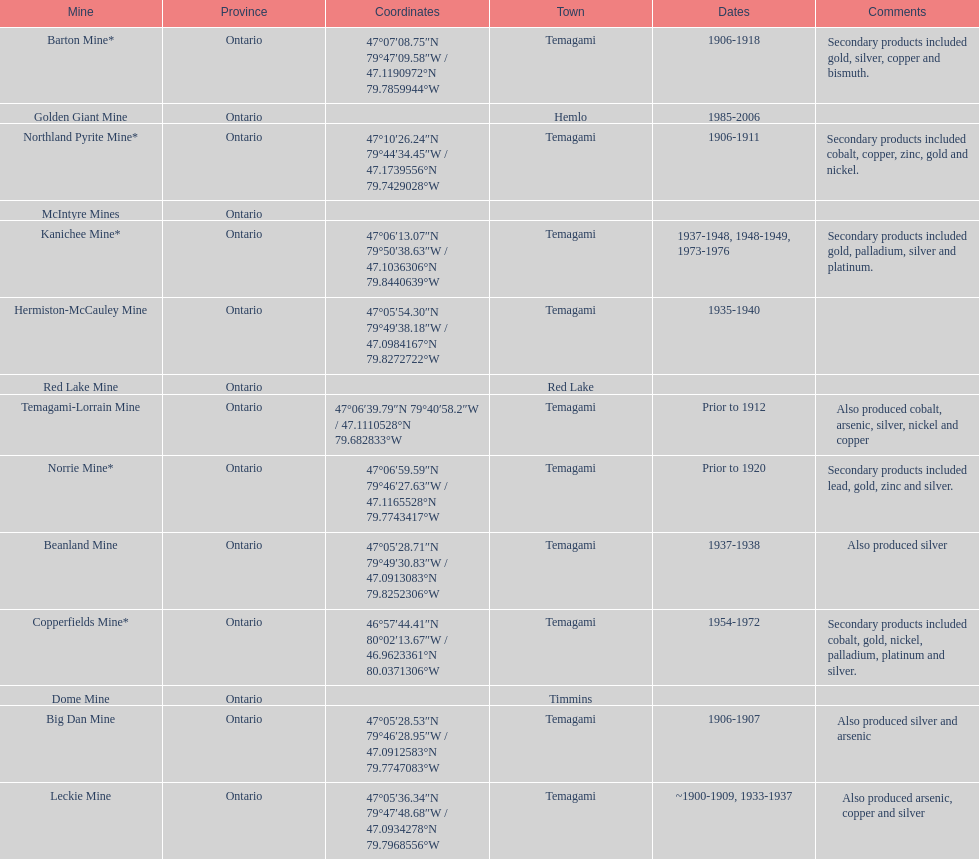How many times is temagami listedon the list? 10. 